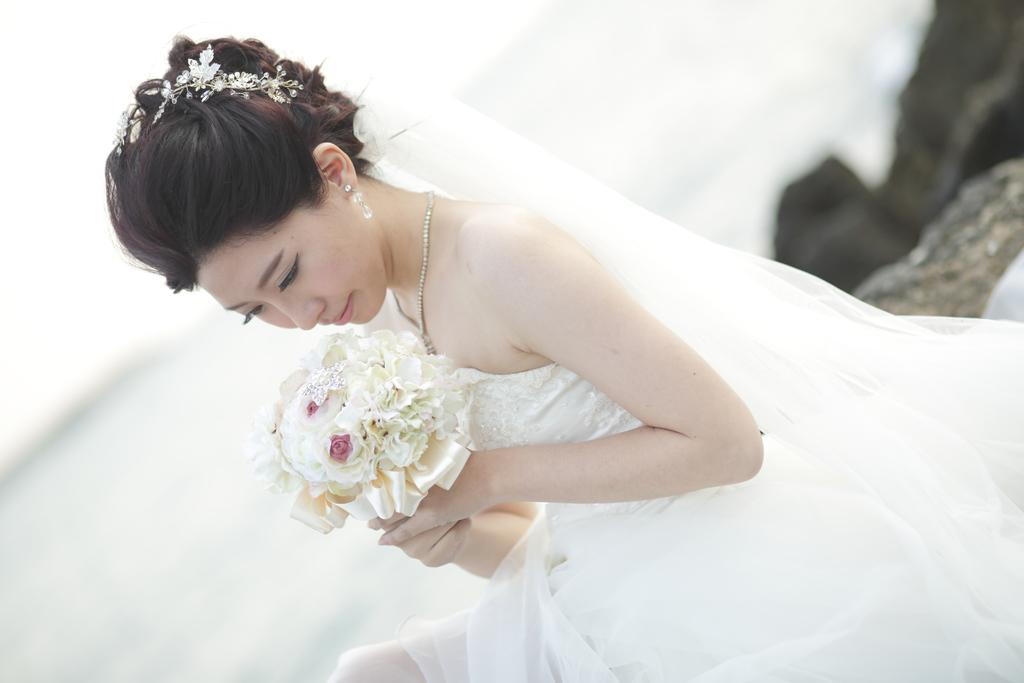Who is the main subject in the image? There is a woman in the image. What is the woman wearing? The woman is wearing a white frock. What is the woman holding in the image? The woman is holding a bouquet. Can you describe the background of the image? The background of the image is blurred. What type of natural elements can be seen in the image? There are rocks visible in the image. What type of note is the woman reading in the image? There is no note present in the image; the woman is holding a bouquet. How many parts of the knife can be seen in the image? There is no knife present in the image. 